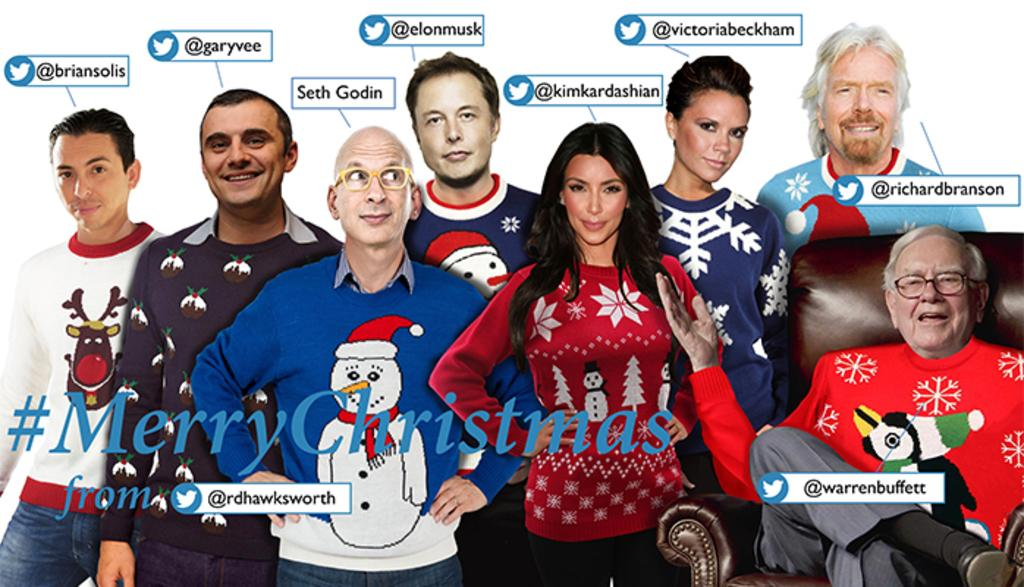<image>
Relay a brief, clear account of the picture shown. A collage of different celebrities share a card which reads Merry Christmas. 